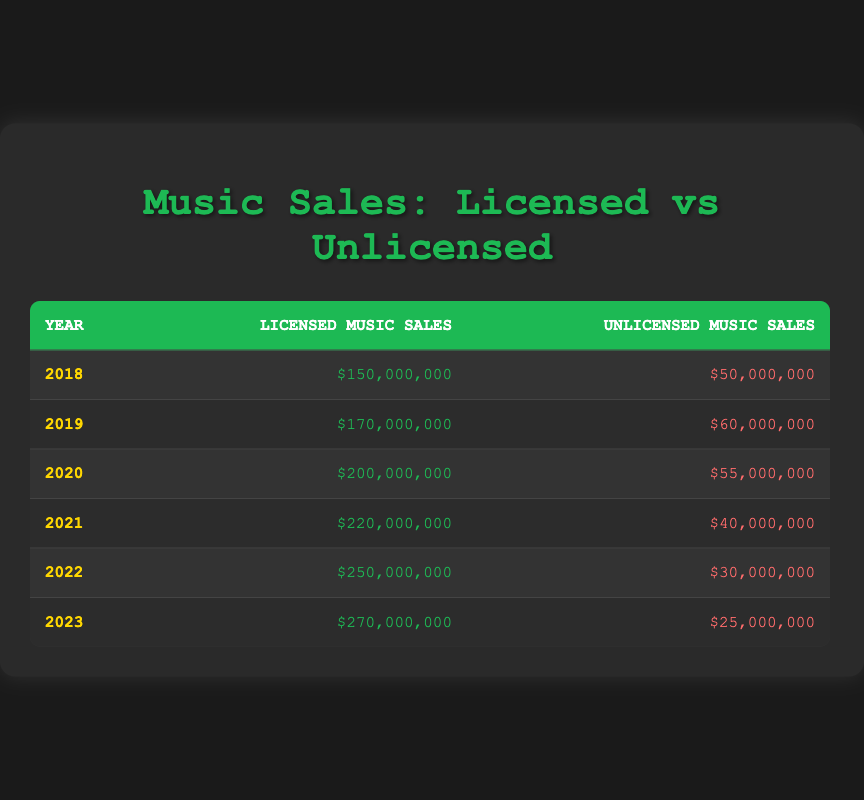What were the licensed music sales in 2021? The table shows that in 2021, the licensed music sales were listed as $220,000,000.
Answer: $220,000,000 What is the total unlicensed music sales from 2018 to 2023? To find the total, we sum the unlicensed sales from each year: 50,000,000 + 60,000,000 + 55,000,000 + 40,000,000 + 30,000,000 + 25,000,000 = 260,000,000.
Answer: $260,000,000 Did unlicensed music sales decrease from 2018 to 2023? Comparing the unlicensed music sales from 2018 ($50,000,000) to 2023 ($25,000,000), we can see that the sales decreased.
Answer: Yes What was the average licensed music sales from 2020 to 2022? First, we find the licensed sales for each year in that range: 200,000,000 (2020), 220,000,000 (2021), 250,000,000 (2022). Their total is 200,000,000 + 220,000,000 + 250,000,000 = 670,000,000. There are 3 years, so we divide by 3: 670,000,000 / 3 = 223,333,333.
Answer: $223,333,333 Which year had the highest difference between licensed and unlicensed music sales? The differences for each year are: 2018: 150,000,000 - 50,000,000 = 100,000,000; 2019: 170,000,000 - 60,000,000 = 110,000,000; 2020: 200,000,000 - 55,000,000 = 145,000,000; 2021: 220,000,000 - 40,000,000 = 180,000,000; 2022: 250,000,000 - 30,000,000 = 220,000,000; 2023: 270,000,000 - 25,000,000 = 245,000,000. The largest difference is in 2023 with 245,000,000.
Answer: 2023 What were the unlicensed music sales in 2020 and 2021 combined? Adding the unlicensed sales for both years gives: 55,000,000 (2020) + 40,000,000 (2021) = 95,000,000.
Answer: $95,000,000 